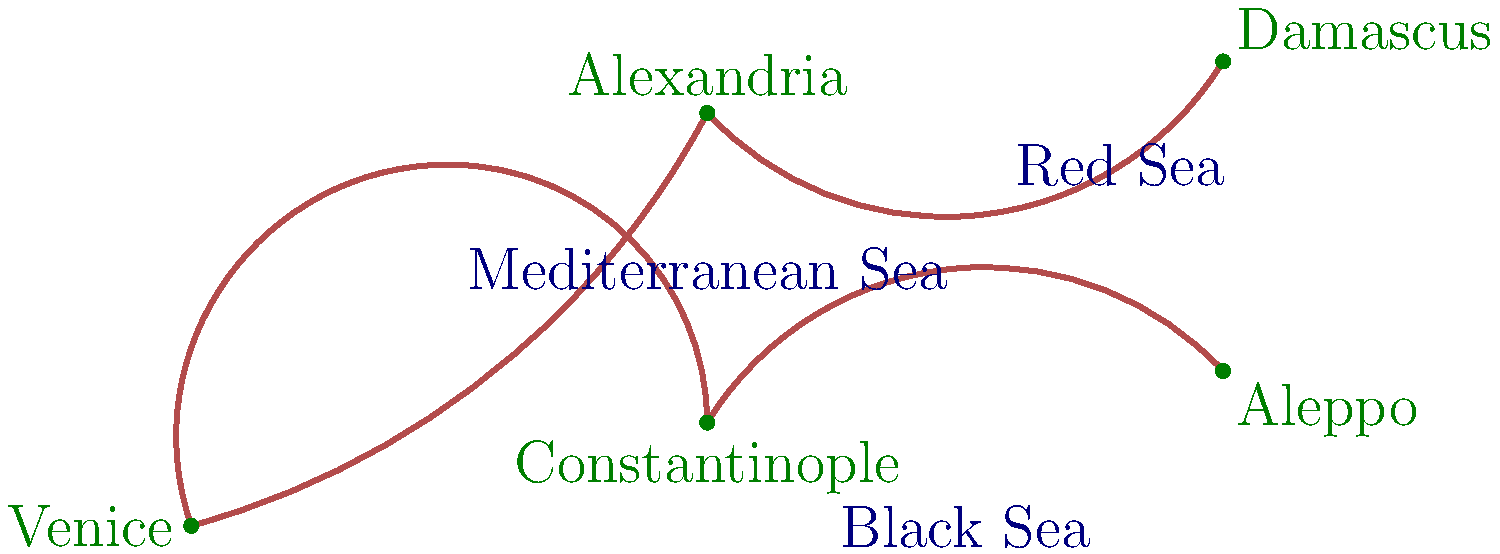Based on the historical map of Renaissance trade routes for exotic herbs, which city served as the primary hub connecting European and Middle Eastern herb markets? To determine the primary hub connecting European and Middle Eastern herb markets during the Renaissance, we need to analyze the trade routes shown on the map:

1. Venice is depicted as the westernmost point, representing the main European market.
2. Constantinople, Alexandria, Aleppo, and Damascus are shown as major Middle Eastern cities involved in the herb trade.
3. The trade routes are represented by the red lines connecting these cities.
4. Examining the map, we can see that all trade routes converge at one central point.
5. This central point is Constantinople, which has direct connections to:
   a) Venice (representing the European market)
   b) Alexandria (a major source of herbs from North Africa and the Red Sea trade)
   c) Aleppo and Damascus (representing the Levantine and Asian herb sources)
6. Constantinople's strategic location at the intersection of these routes made it the ideal hub for connecting European and Middle Eastern herb markets.
7. Historically, Constantinople (modern-day Istanbul) was indeed a crucial center for trade during the Renaissance, particularly for exotic goods like herbs, spices, and textiles.

Therefore, based on the map and historical context, Constantinople served as the primary hub connecting European and Middle Eastern herb markets during the Renaissance period.
Answer: Constantinople 